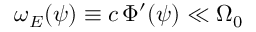<formula> <loc_0><loc_0><loc_500><loc_500>\omega _ { E } ( \psi ) \equiv c \, \Phi ^ { \prime } ( \psi ) \ll \Omega _ { 0 }</formula> 